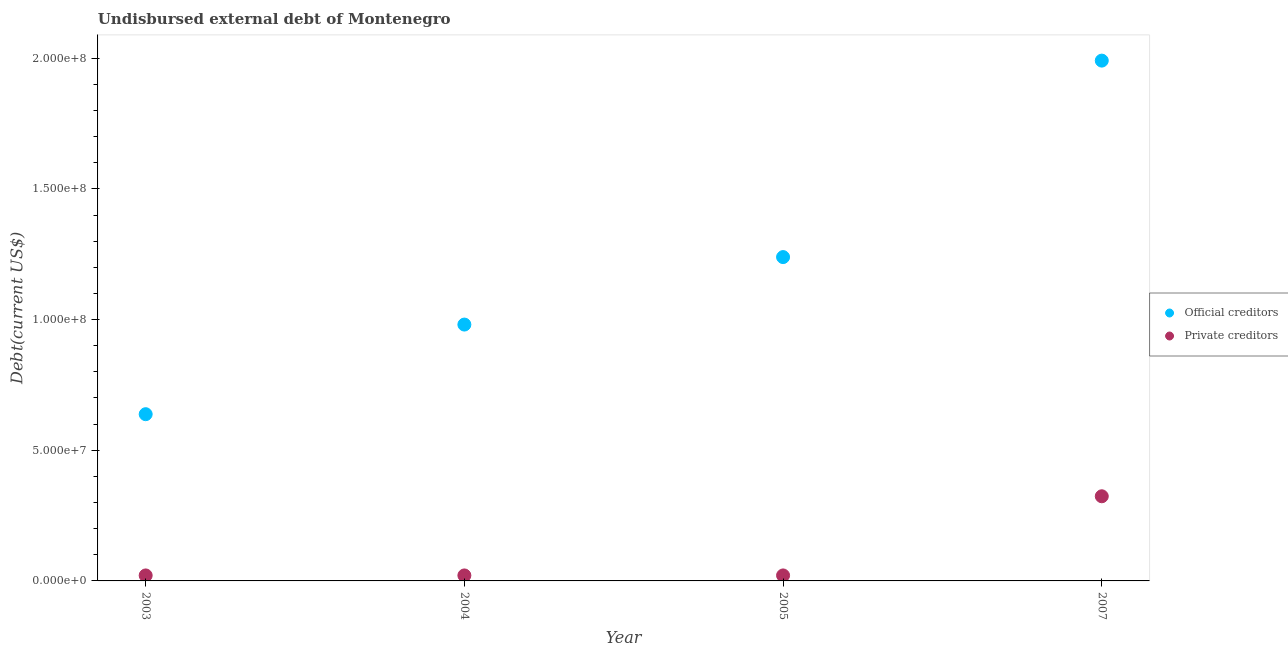How many different coloured dotlines are there?
Offer a very short reply. 2. Is the number of dotlines equal to the number of legend labels?
Provide a short and direct response. Yes. What is the undisbursed external debt of official creditors in 2003?
Ensure brevity in your answer.  6.38e+07. Across all years, what is the maximum undisbursed external debt of private creditors?
Ensure brevity in your answer.  3.24e+07. Across all years, what is the minimum undisbursed external debt of private creditors?
Your answer should be very brief. 2.10e+06. In which year was the undisbursed external debt of official creditors maximum?
Your response must be concise. 2007. What is the total undisbursed external debt of official creditors in the graph?
Offer a terse response. 4.85e+08. What is the difference between the undisbursed external debt of private creditors in 2005 and that in 2007?
Your response must be concise. -3.03e+07. What is the difference between the undisbursed external debt of private creditors in 2007 and the undisbursed external debt of official creditors in 2004?
Provide a short and direct response. -6.57e+07. What is the average undisbursed external debt of official creditors per year?
Provide a short and direct response. 1.21e+08. In the year 2003, what is the difference between the undisbursed external debt of official creditors and undisbursed external debt of private creditors?
Keep it short and to the point. 6.17e+07. What is the ratio of the undisbursed external debt of official creditors in 2003 to that in 2007?
Provide a short and direct response. 0.32. Is the difference between the undisbursed external debt of official creditors in 2004 and 2005 greater than the difference between the undisbursed external debt of private creditors in 2004 and 2005?
Offer a terse response. No. What is the difference between the highest and the second highest undisbursed external debt of official creditors?
Provide a short and direct response. 7.52e+07. What is the difference between the highest and the lowest undisbursed external debt of official creditors?
Make the answer very short. 1.35e+08. In how many years, is the undisbursed external debt of private creditors greater than the average undisbursed external debt of private creditors taken over all years?
Your answer should be very brief. 1. Is the undisbursed external debt of official creditors strictly greater than the undisbursed external debt of private creditors over the years?
Ensure brevity in your answer.  Yes. Is the undisbursed external debt of official creditors strictly less than the undisbursed external debt of private creditors over the years?
Provide a short and direct response. No. How many years are there in the graph?
Give a very brief answer. 4. What is the difference between two consecutive major ticks on the Y-axis?
Your answer should be compact. 5.00e+07. Where does the legend appear in the graph?
Provide a short and direct response. Center right. How are the legend labels stacked?
Your response must be concise. Vertical. What is the title of the graph?
Provide a succinct answer. Undisbursed external debt of Montenegro. Does "Formally registered" appear as one of the legend labels in the graph?
Keep it short and to the point. No. What is the label or title of the Y-axis?
Your response must be concise. Debt(current US$). What is the Debt(current US$) in Official creditors in 2003?
Your answer should be very brief. 6.38e+07. What is the Debt(current US$) of Private creditors in 2003?
Provide a short and direct response. 2.10e+06. What is the Debt(current US$) of Official creditors in 2004?
Give a very brief answer. 9.81e+07. What is the Debt(current US$) of Private creditors in 2004?
Provide a short and direct response. 2.10e+06. What is the Debt(current US$) in Official creditors in 2005?
Keep it short and to the point. 1.24e+08. What is the Debt(current US$) of Private creditors in 2005?
Give a very brief answer. 2.10e+06. What is the Debt(current US$) in Official creditors in 2007?
Ensure brevity in your answer.  1.99e+08. What is the Debt(current US$) in Private creditors in 2007?
Give a very brief answer. 3.24e+07. Across all years, what is the maximum Debt(current US$) of Official creditors?
Your response must be concise. 1.99e+08. Across all years, what is the maximum Debt(current US$) of Private creditors?
Offer a very short reply. 3.24e+07. Across all years, what is the minimum Debt(current US$) of Official creditors?
Give a very brief answer. 6.38e+07. Across all years, what is the minimum Debt(current US$) of Private creditors?
Your response must be concise. 2.10e+06. What is the total Debt(current US$) of Official creditors in the graph?
Provide a short and direct response. 4.85e+08. What is the total Debt(current US$) in Private creditors in the graph?
Offer a terse response. 3.87e+07. What is the difference between the Debt(current US$) of Official creditors in 2003 and that in 2004?
Offer a very short reply. -3.43e+07. What is the difference between the Debt(current US$) in Private creditors in 2003 and that in 2004?
Keep it short and to the point. 0. What is the difference between the Debt(current US$) in Official creditors in 2003 and that in 2005?
Offer a terse response. -6.01e+07. What is the difference between the Debt(current US$) in Private creditors in 2003 and that in 2005?
Offer a terse response. 0. What is the difference between the Debt(current US$) in Official creditors in 2003 and that in 2007?
Ensure brevity in your answer.  -1.35e+08. What is the difference between the Debt(current US$) of Private creditors in 2003 and that in 2007?
Provide a short and direct response. -3.03e+07. What is the difference between the Debt(current US$) of Official creditors in 2004 and that in 2005?
Your response must be concise. -2.58e+07. What is the difference between the Debt(current US$) in Private creditors in 2004 and that in 2005?
Offer a terse response. 0. What is the difference between the Debt(current US$) of Official creditors in 2004 and that in 2007?
Offer a terse response. -1.01e+08. What is the difference between the Debt(current US$) in Private creditors in 2004 and that in 2007?
Give a very brief answer. -3.03e+07. What is the difference between the Debt(current US$) of Official creditors in 2005 and that in 2007?
Offer a terse response. -7.52e+07. What is the difference between the Debt(current US$) of Private creditors in 2005 and that in 2007?
Your answer should be very brief. -3.03e+07. What is the difference between the Debt(current US$) in Official creditors in 2003 and the Debt(current US$) in Private creditors in 2004?
Provide a short and direct response. 6.17e+07. What is the difference between the Debt(current US$) of Official creditors in 2003 and the Debt(current US$) of Private creditors in 2005?
Offer a very short reply. 6.17e+07. What is the difference between the Debt(current US$) in Official creditors in 2003 and the Debt(current US$) in Private creditors in 2007?
Offer a terse response. 3.14e+07. What is the difference between the Debt(current US$) in Official creditors in 2004 and the Debt(current US$) in Private creditors in 2005?
Your answer should be compact. 9.60e+07. What is the difference between the Debt(current US$) of Official creditors in 2004 and the Debt(current US$) of Private creditors in 2007?
Make the answer very short. 6.57e+07. What is the difference between the Debt(current US$) in Official creditors in 2005 and the Debt(current US$) in Private creditors in 2007?
Your answer should be compact. 9.15e+07. What is the average Debt(current US$) of Official creditors per year?
Offer a very short reply. 1.21e+08. What is the average Debt(current US$) in Private creditors per year?
Offer a very short reply. 9.67e+06. In the year 2003, what is the difference between the Debt(current US$) of Official creditors and Debt(current US$) of Private creditors?
Your response must be concise. 6.17e+07. In the year 2004, what is the difference between the Debt(current US$) of Official creditors and Debt(current US$) of Private creditors?
Offer a terse response. 9.60e+07. In the year 2005, what is the difference between the Debt(current US$) in Official creditors and Debt(current US$) in Private creditors?
Make the answer very short. 1.22e+08. In the year 2007, what is the difference between the Debt(current US$) of Official creditors and Debt(current US$) of Private creditors?
Your response must be concise. 1.67e+08. What is the ratio of the Debt(current US$) in Official creditors in 2003 to that in 2004?
Make the answer very short. 0.65. What is the ratio of the Debt(current US$) in Private creditors in 2003 to that in 2004?
Your answer should be compact. 1. What is the ratio of the Debt(current US$) of Official creditors in 2003 to that in 2005?
Keep it short and to the point. 0.51. What is the ratio of the Debt(current US$) in Private creditors in 2003 to that in 2005?
Keep it short and to the point. 1. What is the ratio of the Debt(current US$) in Official creditors in 2003 to that in 2007?
Provide a short and direct response. 0.32. What is the ratio of the Debt(current US$) in Private creditors in 2003 to that in 2007?
Ensure brevity in your answer.  0.06. What is the ratio of the Debt(current US$) of Official creditors in 2004 to that in 2005?
Your answer should be compact. 0.79. What is the ratio of the Debt(current US$) in Private creditors in 2004 to that in 2005?
Make the answer very short. 1. What is the ratio of the Debt(current US$) in Official creditors in 2004 to that in 2007?
Give a very brief answer. 0.49. What is the ratio of the Debt(current US$) of Private creditors in 2004 to that in 2007?
Keep it short and to the point. 0.06. What is the ratio of the Debt(current US$) in Official creditors in 2005 to that in 2007?
Your answer should be very brief. 0.62. What is the ratio of the Debt(current US$) in Private creditors in 2005 to that in 2007?
Offer a terse response. 0.06. What is the difference between the highest and the second highest Debt(current US$) in Official creditors?
Provide a succinct answer. 7.52e+07. What is the difference between the highest and the second highest Debt(current US$) in Private creditors?
Provide a short and direct response. 3.03e+07. What is the difference between the highest and the lowest Debt(current US$) in Official creditors?
Provide a succinct answer. 1.35e+08. What is the difference between the highest and the lowest Debt(current US$) of Private creditors?
Offer a terse response. 3.03e+07. 